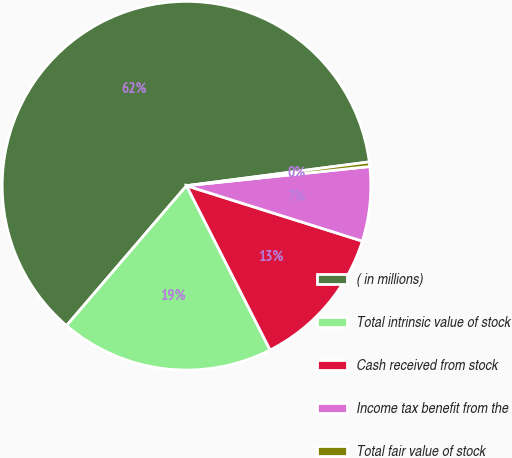Convert chart to OTSL. <chart><loc_0><loc_0><loc_500><loc_500><pie_chart><fcel>( in millions)<fcel>Total intrinsic value of stock<fcel>Cash received from stock<fcel>Income tax benefit from the<fcel>Total fair value of stock<nl><fcel>61.65%<fcel>18.77%<fcel>12.65%<fcel>6.52%<fcel>0.4%<nl></chart> 